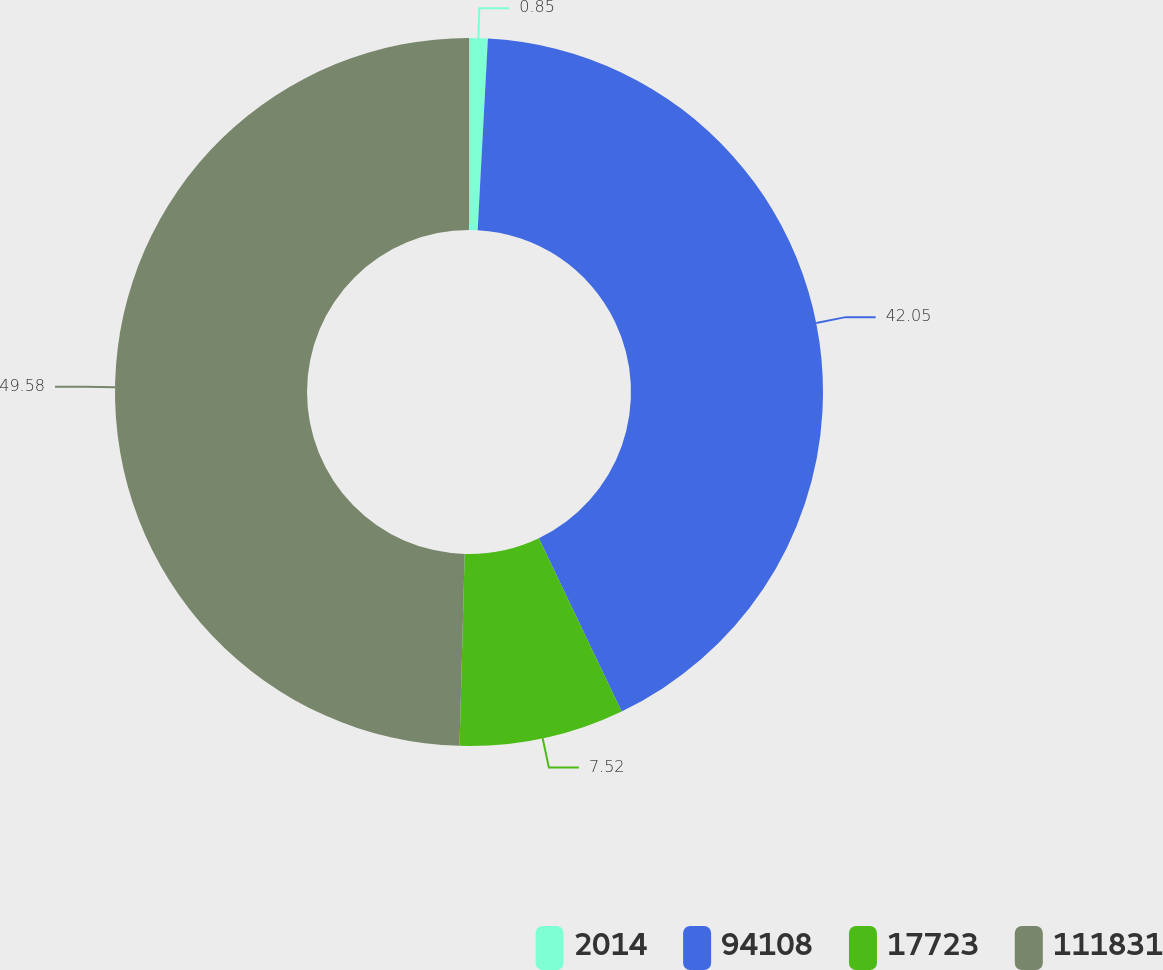Convert chart to OTSL. <chart><loc_0><loc_0><loc_500><loc_500><pie_chart><fcel>2014<fcel>94108<fcel>17723<fcel>111831<nl><fcel>0.85%<fcel>42.05%<fcel>7.52%<fcel>49.57%<nl></chart> 